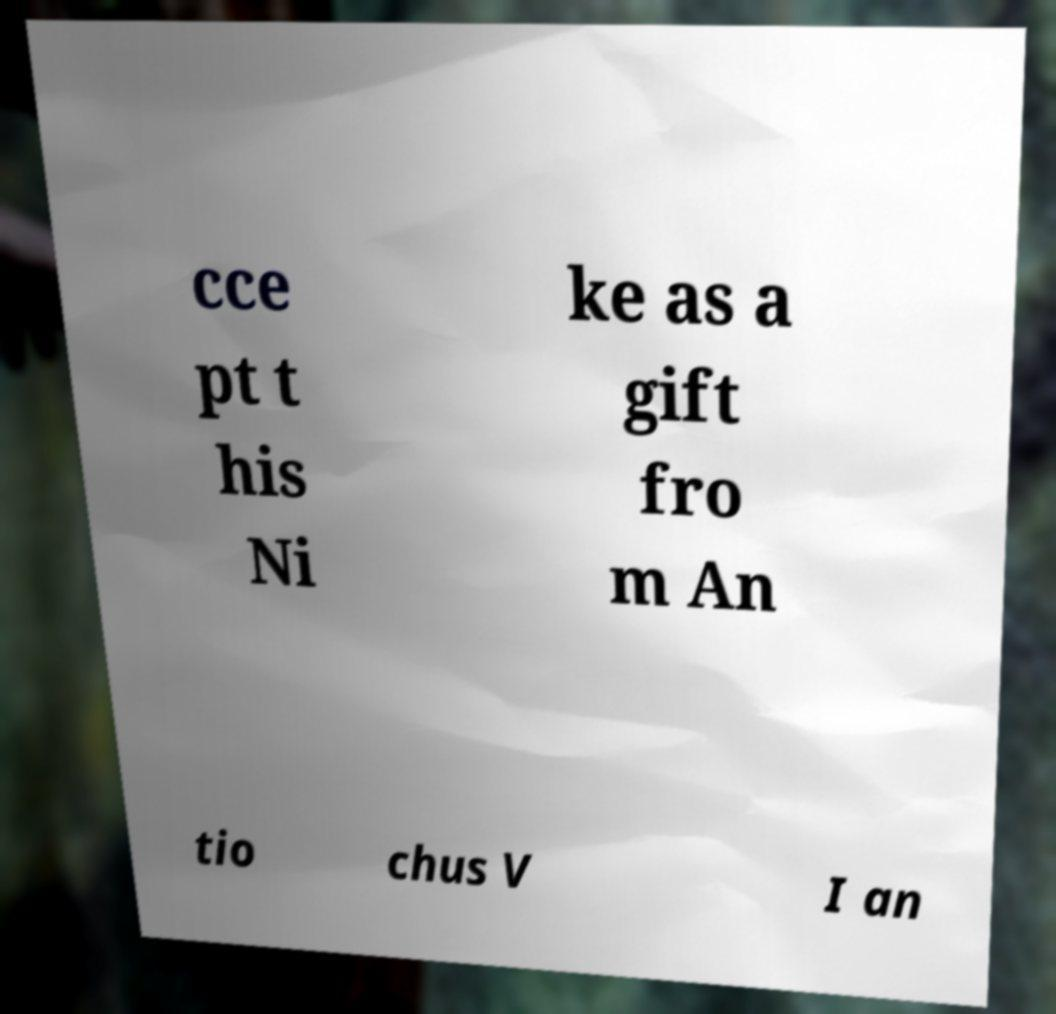Could you assist in decoding the text presented in this image and type it out clearly? cce pt t his Ni ke as a gift fro m An tio chus V I an 